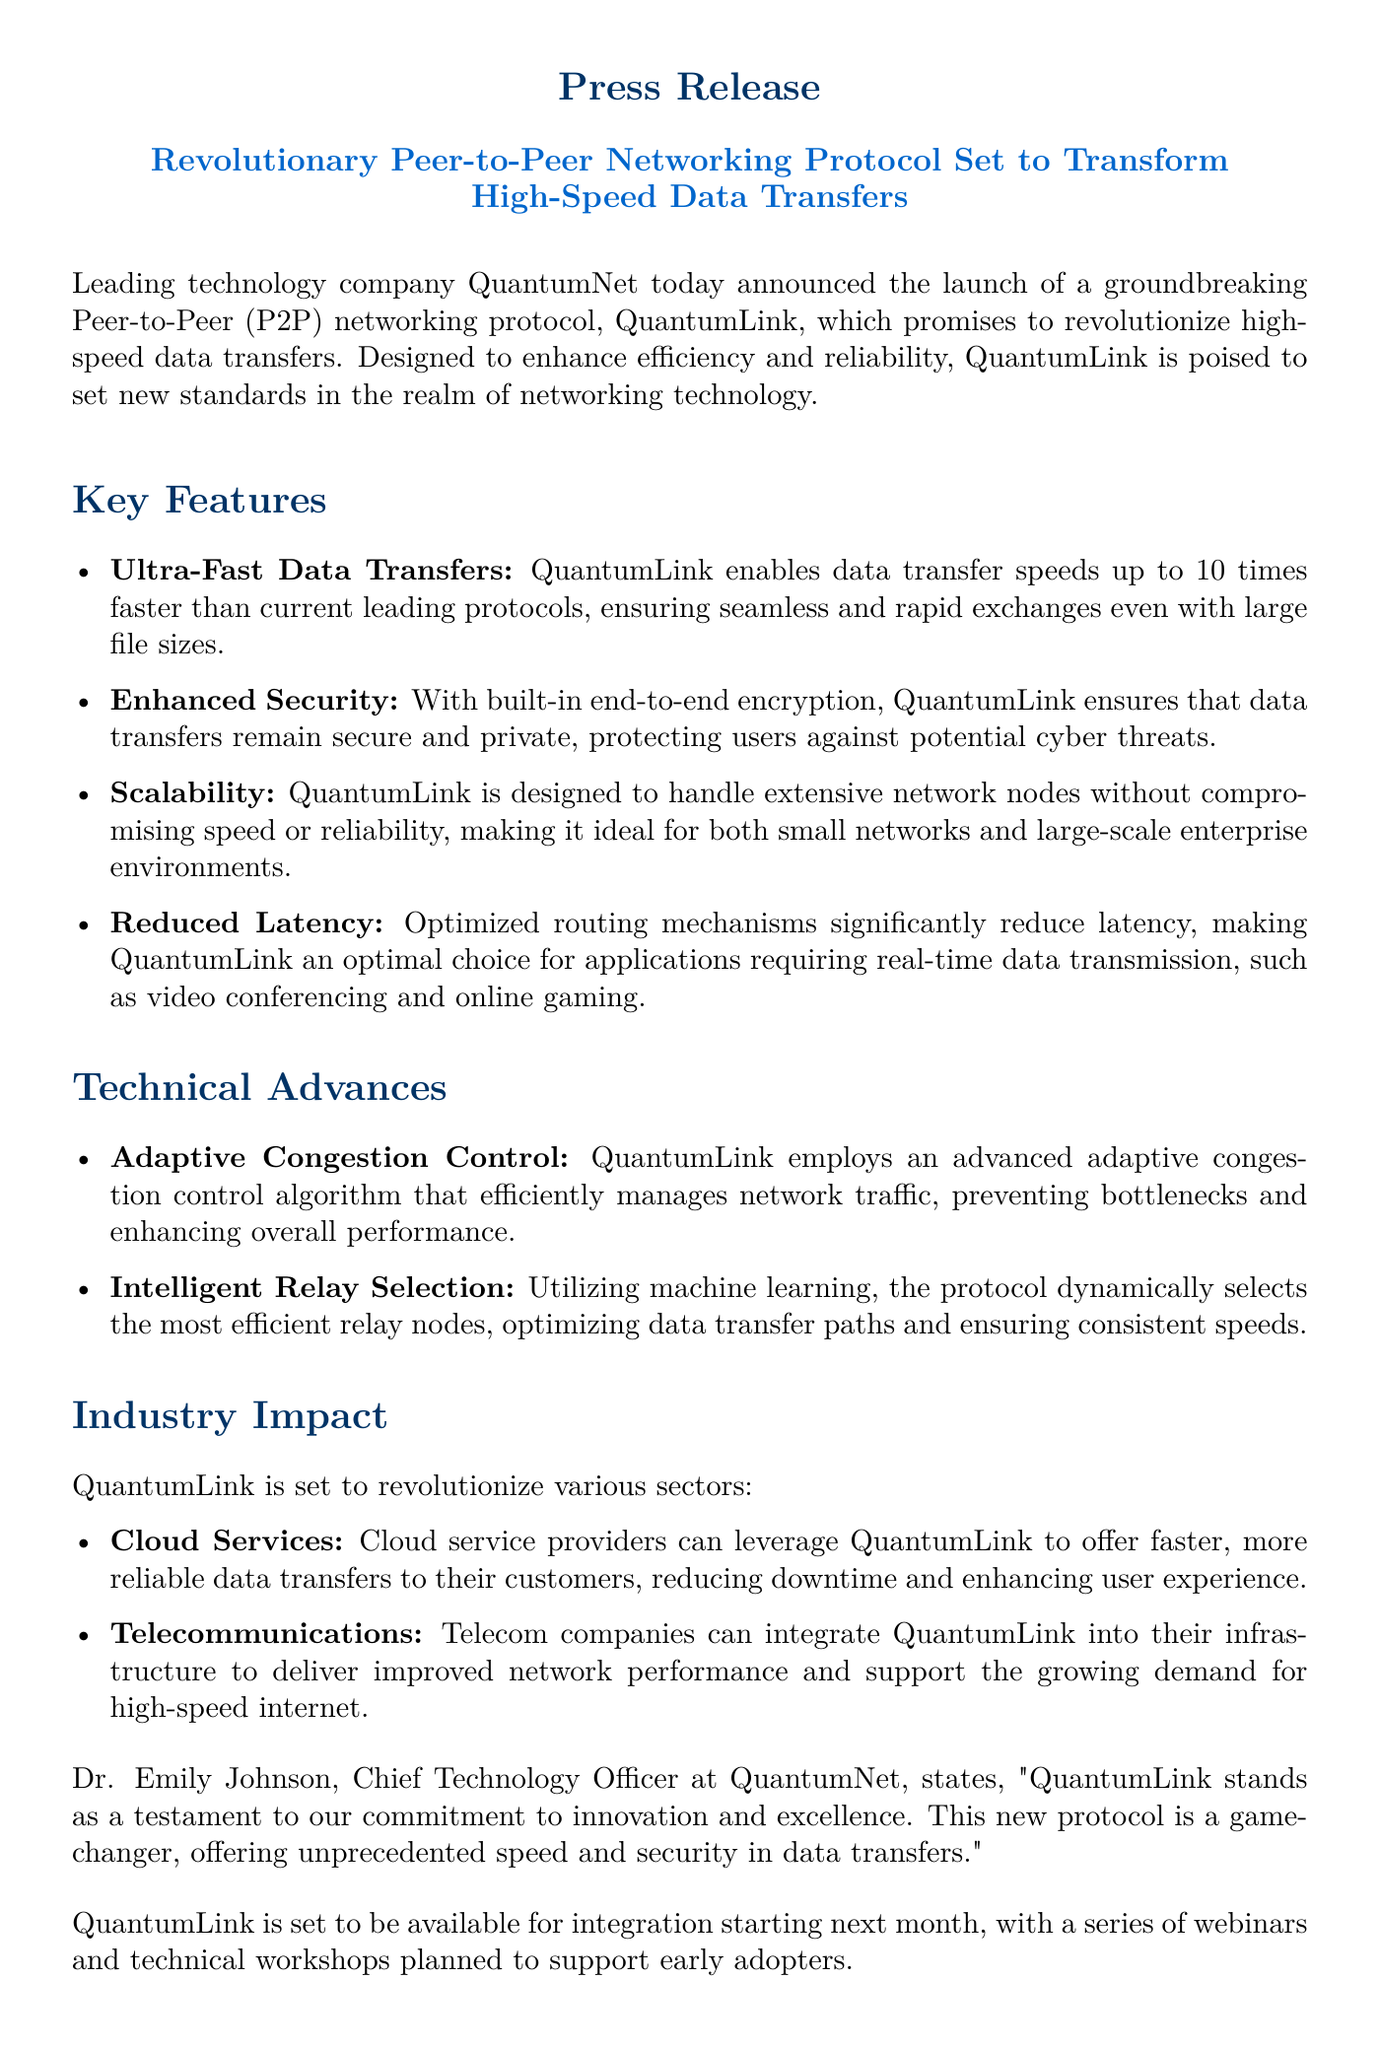What is the name of the new protocol? The new protocol launched by QuantumNet is called QuantumLink.
Answer: QuantumLink What is the data transfer speed of QuantumLink compared to current protocols? QuantumLink enables data transfer speeds up to 10 times faster than current leading protocols.
Answer: 10 times faster What type of encryption does QuantumLink use? QuantumLink features built-in end-to-end encryption for data transfers.
Answer: end-to-end encryption Who is the Chief Technology Officer at QuantumNet? Dr. Emily Johnson is the Chief Technology Officer at QuantumNet.
Answer: Dr. Emily Johnson What month will QuantumLink be available for integration? QuantumLink is set to be available for integration starting next month.
Answer: next month Which sectors will QuantumLink impact? QuantumLink is set to revolutionize sectors such as cloud services and telecommunications.
Answer: cloud services and telecommunications What algorithm does QuantumLink employ to manage network traffic? QuantumLink employs an advanced adaptive congestion control algorithm.
Answer: adaptive congestion control Which feature of QuantumLink reduces latency? Optimized routing mechanisms significantly reduce latency in QuantumLink.
Answer: optimized routing mechanisms What does QuantumLink utilize to optimize data transfer paths? QuantumLink utilizes machine learning to dynamically select the most efficient relay nodes.
Answer: machine learning 